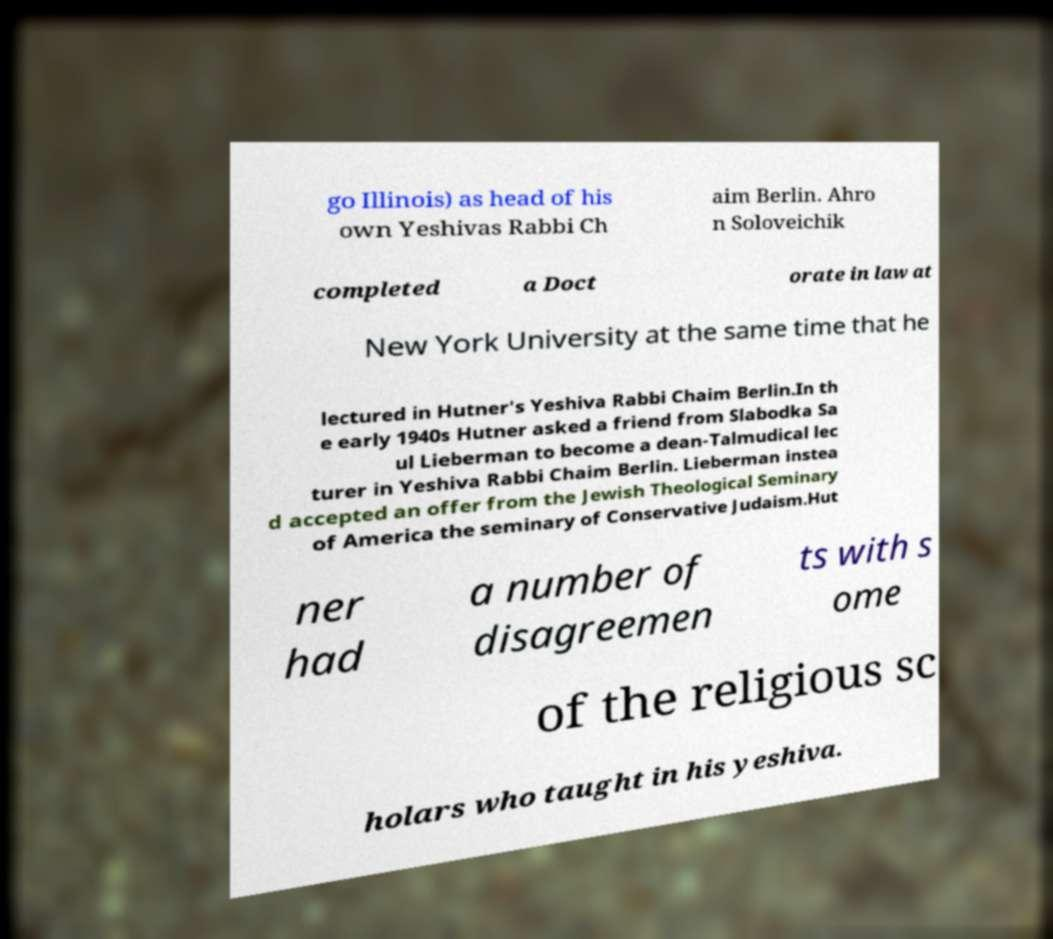Can you accurately transcribe the text from the provided image for me? go Illinois) as head of his own Yeshivas Rabbi Ch aim Berlin. Ahro n Soloveichik completed a Doct orate in law at New York University at the same time that he lectured in Hutner's Yeshiva Rabbi Chaim Berlin.In th e early 1940s Hutner asked a friend from Slabodka Sa ul Lieberman to become a dean-Talmudical lec turer in Yeshiva Rabbi Chaim Berlin. Lieberman instea d accepted an offer from the Jewish Theological Seminary of America the seminary of Conservative Judaism.Hut ner had a number of disagreemen ts with s ome of the religious sc holars who taught in his yeshiva. 